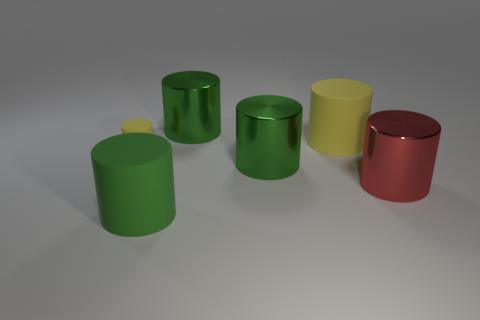Do the red cylinder and the object that is in front of the red cylinder have the same size?
Give a very brief answer. Yes. Is there any other thing that has the same shape as the big red shiny object?
Offer a very short reply. Yes. What is the size of the red thing?
Provide a succinct answer. Large. Is the number of large green metallic cylinders that are in front of the big red metallic thing less than the number of green rubber cylinders?
Keep it short and to the point. Yes. Do the red shiny cylinder and the green rubber thing have the same size?
Your response must be concise. Yes. What is the color of the big object that is the same material as the big yellow cylinder?
Your response must be concise. Green. Are there fewer yellow rubber cylinders to the left of the small cylinder than yellow cylinders behind the big red metallic object?
Ensure brevity in your answer.  Yes. What number of other things are the same color as the small thing?
Offer a very short reply. 1. What number of green objects are behind the tiny thing and in front of the red cylinder?
Ensure brevity in your answer.  0. There is a yellow cylinder that is to the right of the big green thing that is in front of the red metal thing; what is it made of?
Offer a very short reply. Rubber. 